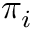<formula> <loc_0><loc_0><loc_500><loc_500>\pi _ { i }</formula> 